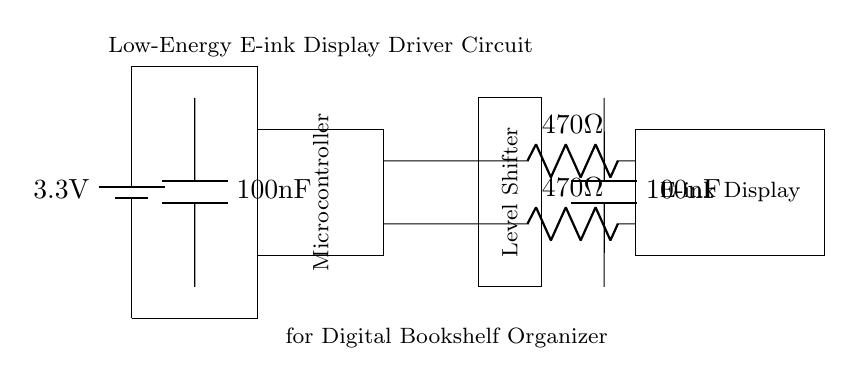What is the voltage of this circuit? The voltage is 3.3 volts, which is indicated by the symbol of the battery connected at the top. The component label directly states the voltage supplied.
Answer: 3.3 volts What type of display is used in this circuit? The display type is an E-ink Display, which is highlighted in the diagram as a rectangle labeled accordingly. This type of display is noted for its low power consumption.
Answer: E-ink Display What is the resistance value of the resistors used? There are two resistors in the circuit, each labeled as 470 ohms. The labels are positioned adjacent to the resistor symbols, clearly stating their values.
Answer: 470 ohms What component is responsible for voltage level shifting? The component responsible for voltage level shifting is the Level Shifter, which is drawn as a rectangle in the diagram and labeled accordingly. It connects the microcontroller to the E-ink display at different voltage levels.
Answer: Level Shifter How many decoupling capacitors are used in this circuit? There are two decoupling capacitors in the circuit, each labeled as 100 nanofarads. They are visible in the diagram, connected to the power supply lines, helping to stabilize voltage levels.
Answer: Two What is the purpose of the decoupling capacitors in this circuit? The purpose of the decoupling capacitors is to filter out noise from the power supply and stabilize voltage levels, ensuring reliable operation of the microcontroller and display. They are located close to the respective devices they support.
Answer: Filter noise What type of circuit is this implementation? This is a low-energy circuit designed specifically for a digital bookshelf organizer. This is inferred from the circuit's components and their design for efficient power consumption, as indicated in the labels.
Answer: Low-energy circuit 